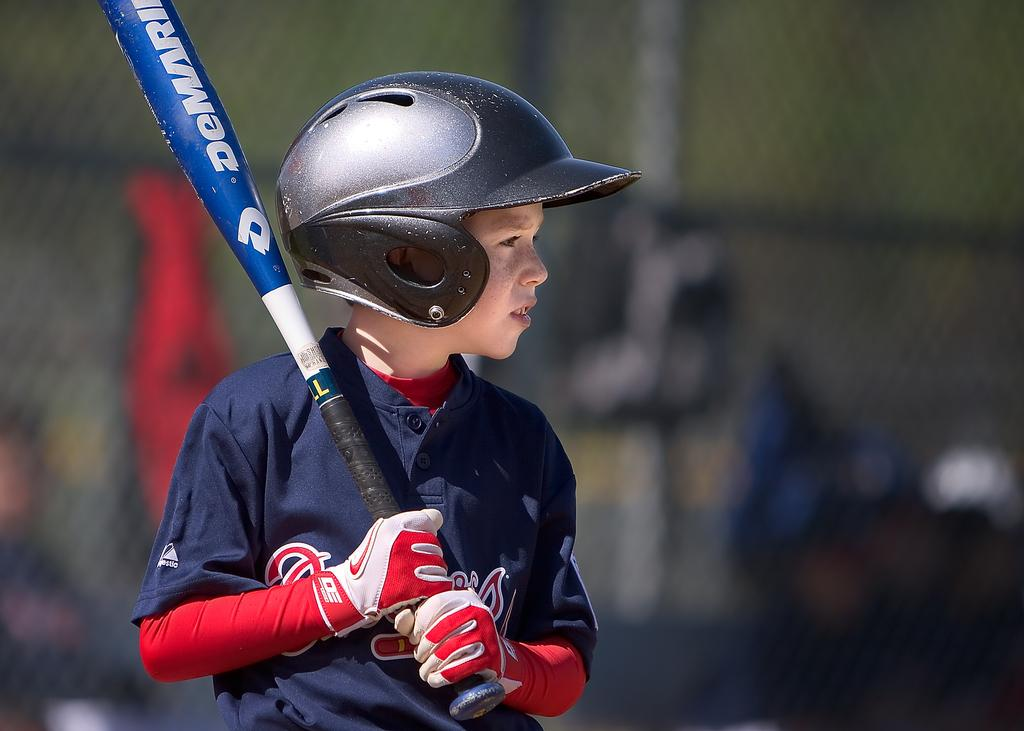Who is the main subject in the image? There is a boy in the image. What is the boy doing in the image? The boy is standing in the image. What is the boy holding in his hands? The boy is holding a stick in his hands. What is the boy wearing on his upper body? The boy is wearing a blue t-shirt. What protective gear is the boy wearing? The boy is wearing a helmet. How would you describe the background of the image? The background of the image is blurry. What type of office equipment can be seen in the image? There is no office equipment present in the image. How fast is the boy running in the image? The boy is not running in the image; he is standing still. 